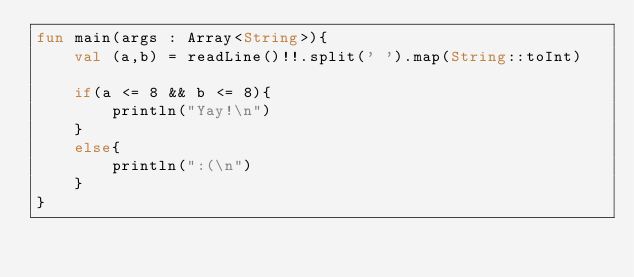<code> <loc_0><loc_0><loc_500><loc_500><_Kotlin_>fun main(args : Array<String>){
    val (a,b) = readLine()!!.split(' ').map(String::toInt)

    if(a <= 8 && b <= 8){
        println("Yay!\n")
    }
    else{
        println(":(\n")
    }
}</code> 